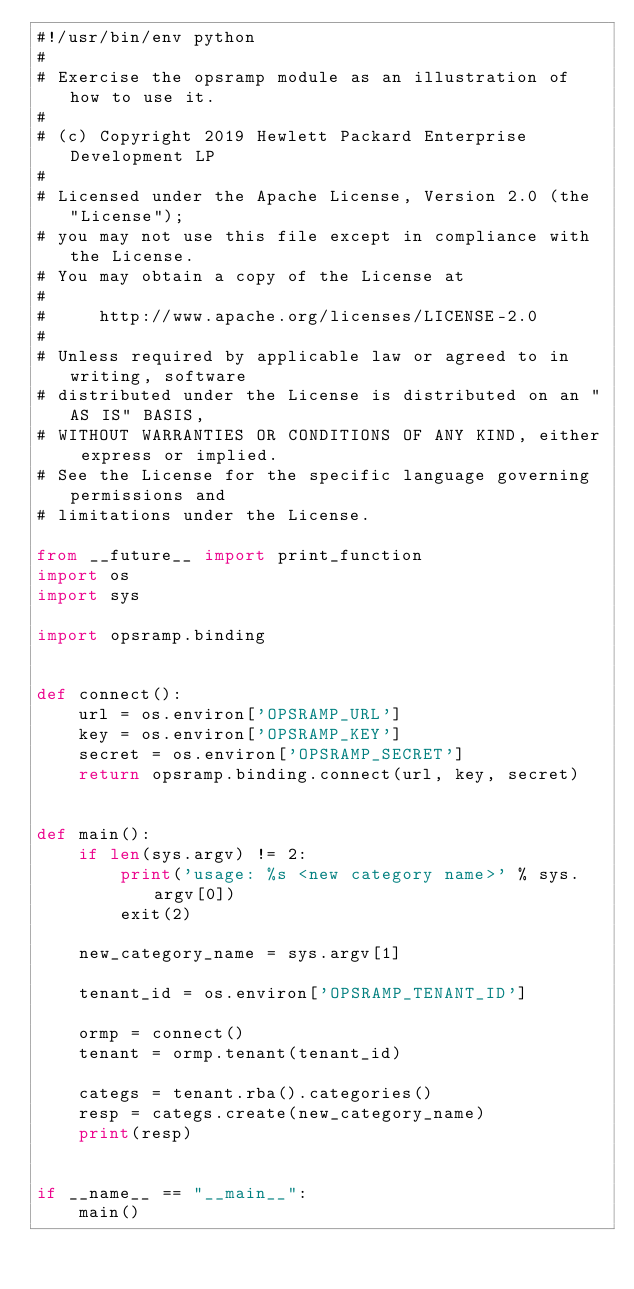<code> <loc_0><loc_0><loc_500><loc_500><_Python_>#!/usr/bin/env python
#
# Exercise the opsramp module as an illustration of how to use it.
#
# (c) Copyright 2019 Hewlett Packard Enterprise Development LP
#
# Licensed under the Apache License, Version 2.0 (the "License");
# you may not use this file except in compliance with the License.
# You may obtain a copy of the License at
#
#     http://www.apache.org/licenses/LICENSE-2.0
#
# Unless required by applicable law or agreed to in writing, software
# distributed under the License is distributed on an "AS IS" BASIS,
# WITHOUT WARRANTIES OR CONDITIONS OF ANY KIND, either express or implied.
# See the License for the specific language governing permissions and
# limitations under the License.

from __future__ import print_function
import os
import sys

import opsramp.binding


def connect():
    url = os.environ['OPSRAMP_URL']
    key = os.environ['OPSRAMP_KEY']
    secret = os.environ['OPSRAMP_SECRET']
    return opsramp.binding.connect(url, key, secret)


def main():
    if len(sys.argv) != 2:
        print('usage: %s <new category name>' % sys.argv[0])
        exit(2)

    new_category_name = sys.argv[1]

    tenant_id = os.environ['OPSRAMP_TENANT_ID']

    ormp = connect()
    tenant = ormp.tenant(tenant_id)

    categs = tenant.rba().categories()
    resp = categs.create(new_category_name)
    print(resp)


if __name__ == "__main__":
    main()
</code> 